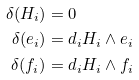Convert formula to latex. <formula><loc_0><loc_0><loc_500><loc_500>\delta ( H _ { i } ) & = 0 \\ \delta ( e _ { i } ) & = d _ { i } H _ { i } \wedge e _ { i } \\ \delta ( f _ { i } ) & = d _ { i } H _ { i } \wedge f _ { i }</formula> 